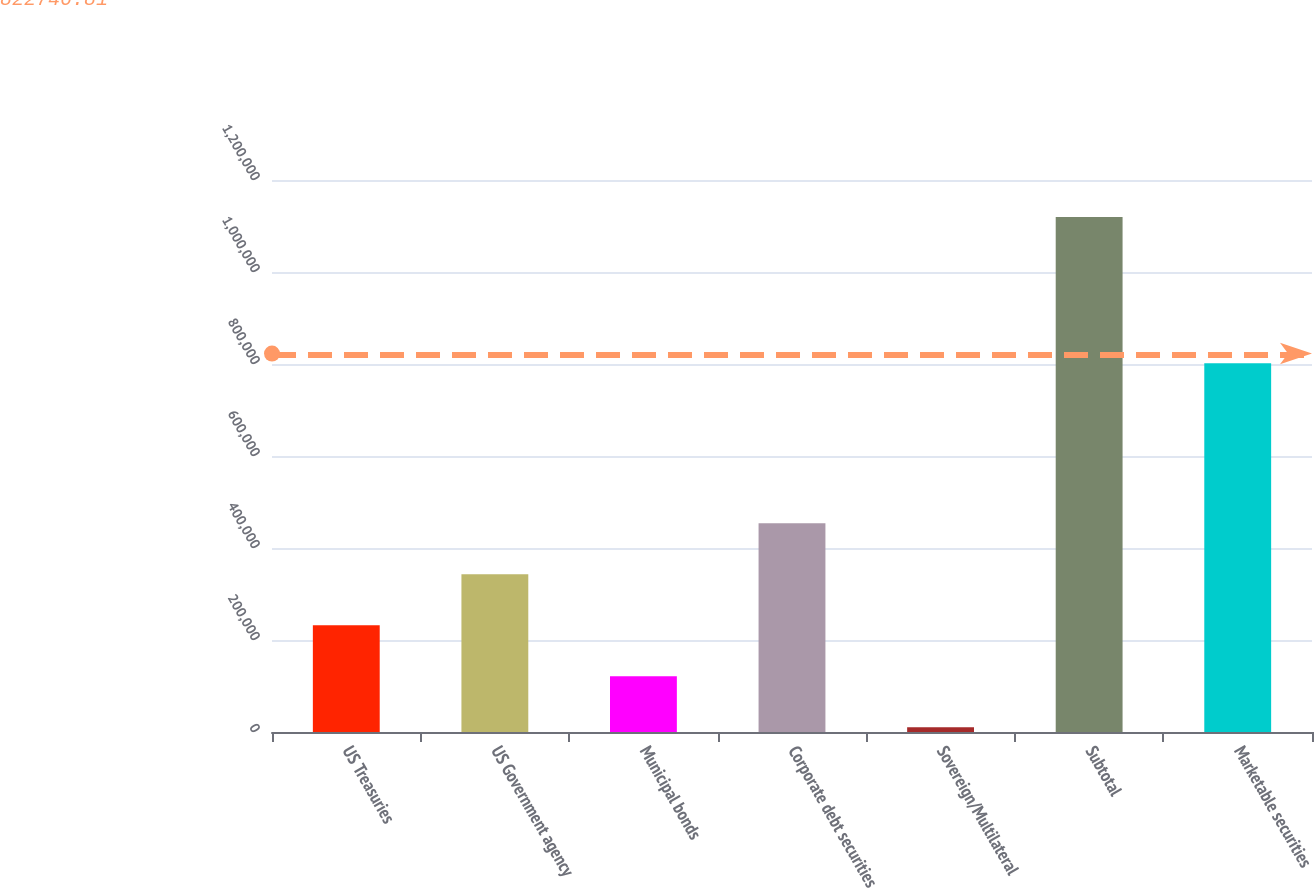Convert chart to OTSL. <chart><loc_0><loc_0><loc_500><loc_500><bar_chart><fcel>US Treasuries<fcel>US Government agency<fcel>Municipal bonds<fcel>Corporate debt securities<fcel>Sovereign/Multilateral<fcel>Subtotal<fcel>Marketable securities<nl><fcel>232123<fcel>343025<fcel>121221<fcel>453927<fcel>10319<fcel>1.11934e+06<fcel>801741<nl></chart> 